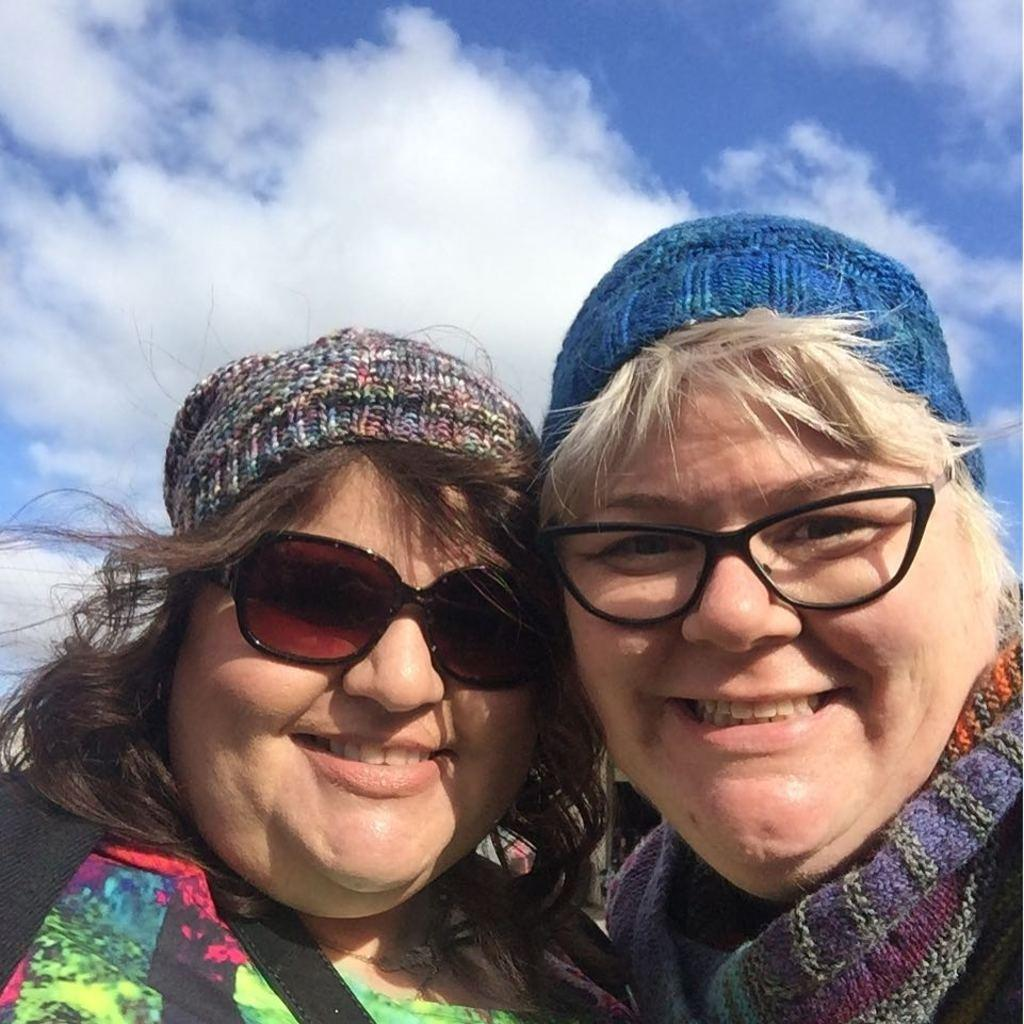How many women are in the image? There are two women in the image. What are the women wearing? Both women are wearing glasses. What are the women doing in the image? The women are holding each other. What can be seen in the background of the image? The sky is visible in the background of the image. How would you describe the weather based on the sky in the image? The sky appears cloudy, which might suggest overcast or potentially rainy weather. How many horses are visible in the image? There are no horses present in the image. What type of bird is perched on the shoulder of one of the women? There is no bird, specifically a wren, present in the image. 